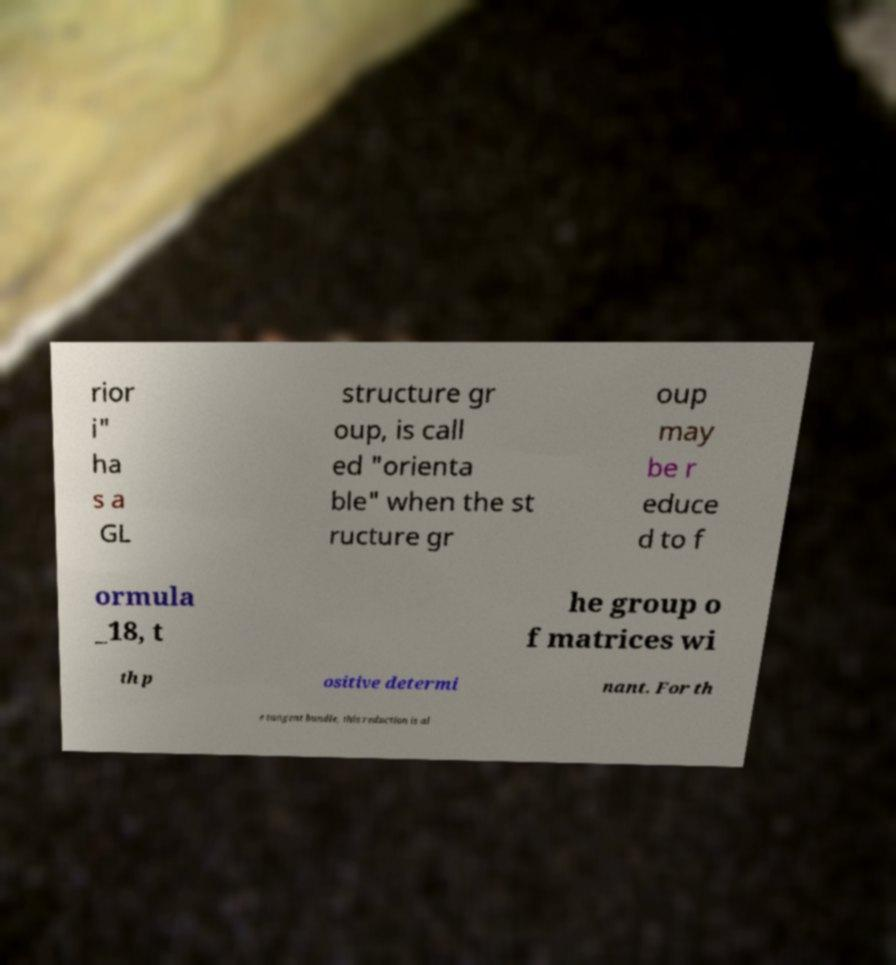There's text embedded in this image that I need extracted. Can you transcribe it verbatim? rior i" ha s a GL structure gr oup, is call ed "orienta ble" when the st ructure gr oup may be r educe d to f ormula _18, t he group o f matrices wi th p ositive determi nant. For th e tangent bundle, this reduction is al 